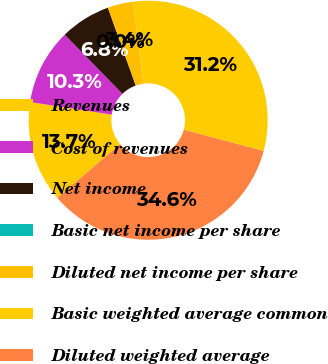Convert chart. <chart><loc_0><loc_0><loc_500><loc_500><pie_chart><fcel>Revenues<fcel>Cost of revenues<fcel>Net income<fcel>Basic net income per share<fcel>Diluted net income per share<fcel>Basic weighted average common<fcel>Diluted weighted average<nl><fcel>13.68%<fcel>10.26%<fcel>6.84%<fcel>0.0%<fcel>3.42%<fcel>31.2%<fcel>34.61%<nl></chart> 